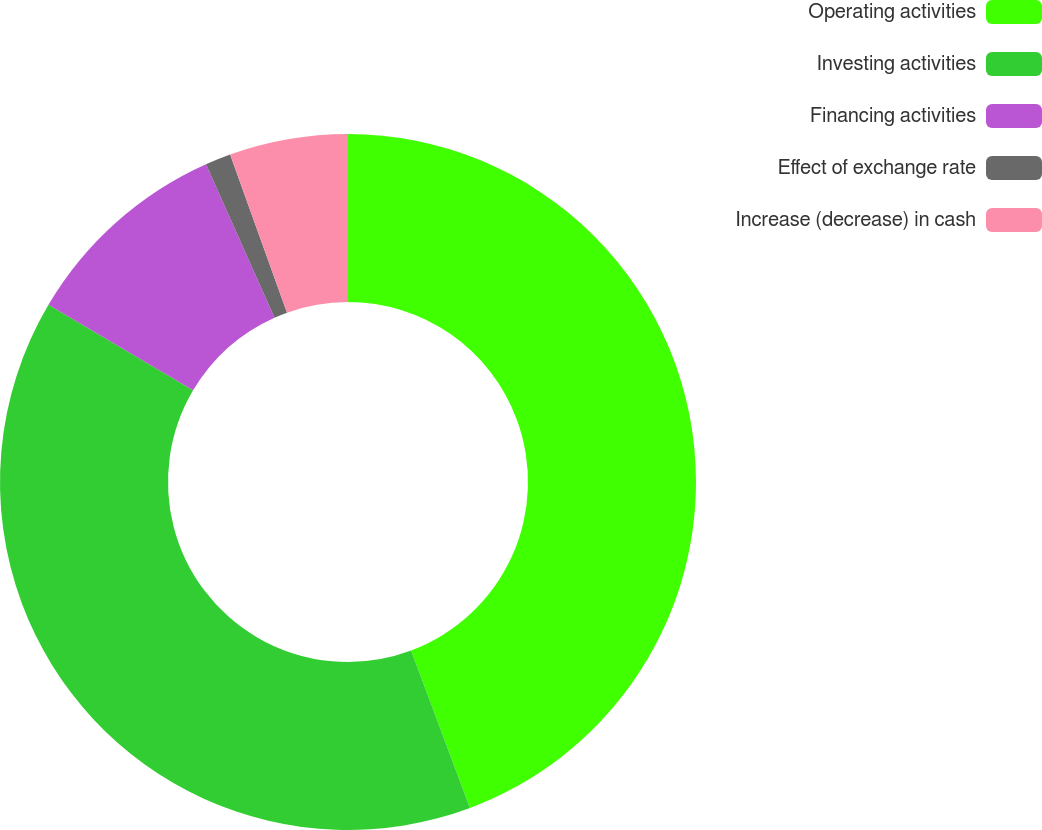<chart> <loc_0><loc_0><loc_500><loc_500><pie_chart><fcel>Operating activities<fcel>Investing activities<fcel>Financing activities<fcel>Effect of exchange rate<fcel>Increase (decrease) in cash<nl><fcel>44.3%<fcel>39.2%<fcel>9.81%<fcel>1.19%<fcel>5.5%<nl></chart> 